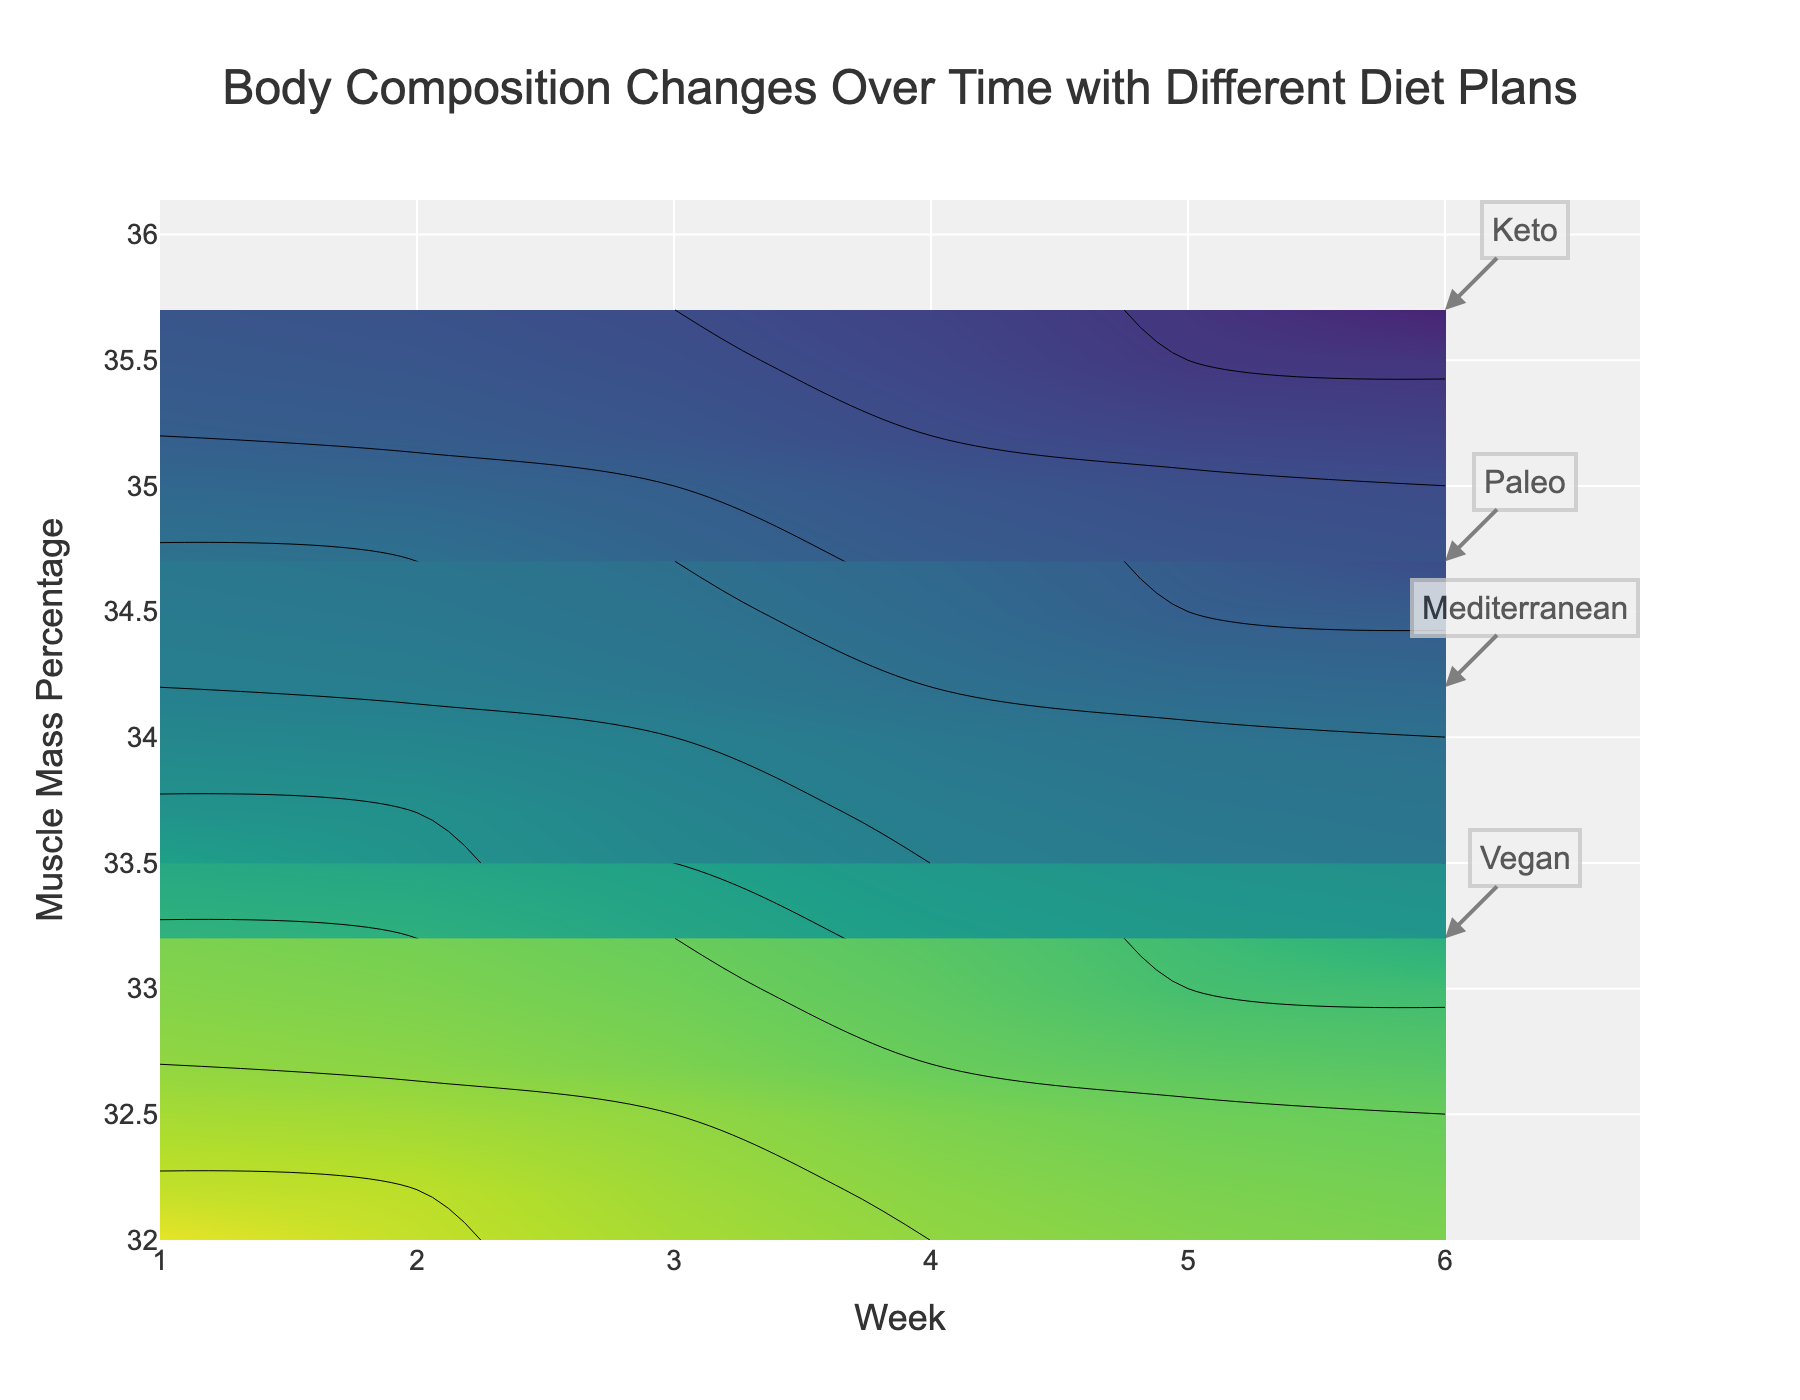What's the title of the figure? The title is usually placed at the top of the figure and is prominently displayed. In this figure, the title is 'Body Composition Changes Over Time with Different Diet Plans'.
Answer: Body Composition Changes Over Time with Different Diet Plans What is shown on the x-axis of the figure? The x-axis represents the passage of time in weeks. You can see the label "Week" along the horizontal axis of the plot.
Answer: Week What diet shows the greatest decrease in body fat percentage from Week 1 to Week 6? To determine this, compare the body fat percentage at Week 1 and Week 6 for each diet. Keto starts at 28.0% and ends at 25.5%. Mediterranean starts at 30.0% and ends at 27.5%. Vegan starts at 32.0% and ends at 29.5%. Paleo starts at 29.0% and ends at 26.5%. The Keto diet shows the greatest decrease (2.5%).
Answer: Keto Which diet shows the greatest increase in muscle mass percentage over time? To find this, look at the muscle mass percentages at Week 1 and Week 6 for each diet. Calculate the increase for each: Keto (35.7-34.5=1.2), Mediterranean (34.2-33.0=1.2), Vegan (33.2-32.0=1.2), Paleo (34.7-33.5=1.2). Since the increase is the same for all, any one can be chosen as the answer.
Answer: Keto (and others) What is the body fat percentage range covered in the plot? The contour plot colors represent different ranges of body fat percentage values. By observing the legend or the contour levels, one can see that the range covers values from 25% to 32%.
Answer: 25% to 32% Which diet plan consistently shows body fat percentage below 27.0% by the 4th week? Examine each diet’s body fat percentage by the end of the 4th week. Both Keto (26.5%) and Paleo (27.5%, only just under) are below 27% by Week 4.
Answer: Keto For the Mediterranean diet, what is the muscle mass percentage at Week 3? Locate the Mediterranean diet data for Week 3 and find the corresponding muscle mass percentage value. The value is 33.5%.
Answer: 33.5% How does the muscle mass percentage change for the Vegan diet from Week 1 to Week 6? Find the muscle mass percentage at Week 1 and Week 6 for the Vegan diet and calculate the change (33.2% - 32.0% = 1.2%). This indicates an increase of 1.2%.
Answer: 1.2% What's the overall trend for body fat percentage in the Paleo diet? Examine the body fat percentages over time for the Paleo diet (29%, 28.5%, 28%, 27.5%, 27%, 26.5%) and observe that it consistently decreases.
Answer: Consistently decreases 